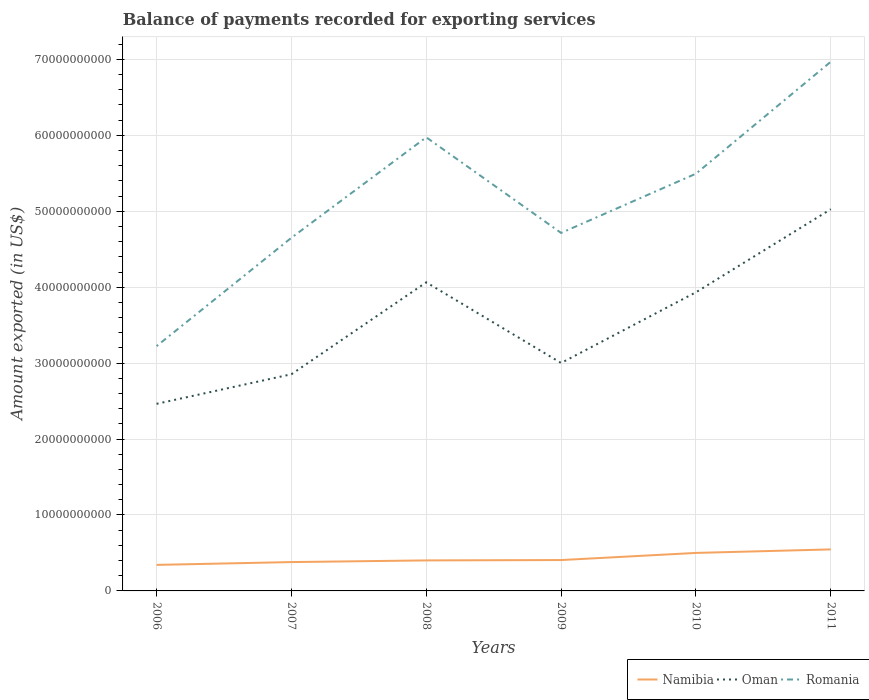How many different coloured lines are there?
Give a very brief answer. 3. Does the line corresponding to Oman intersect with the line corresponding to Namibia?
Your answer should be very brief. No. Is the number of lines equal to the number of legend labels?
Provide a succinct answer. Yes. Across all years, what is the maximum amount exported in Namibia?
Offer a very short reply. 3.43e+09. In which year was the amount exported in Namibia maximum?
Give a very brief answer. 2006. What is the total amount exported in Oman in the graph?
Your answer should be compact. -1.47e+1. What is the difference between the highest and the second highest amount exported in Oman?
Offer a terse response. 2.56e+1. What is the difference between the highest and the lowest amount exported in Romania?
Your response must be concise. 3. Is the amount exported in Oman strictly greater than the amount exported in Romania over the years?
Your answer should be compact. Yes. How many years are there in the graph?
Keep it short and to the point. 6. What is the difference between two consecutive major ticks on the Y-axis?
Your answer should be very brief. 1.00e+1. Does the graph contain any zero values?
Make the answer very short. No. How are the legend labels stacked?
Offer a terse response. Horizontal. What is the title of the graph?
Offer a very short reply. Balance of payments recorded for exporting services. What is the label or title of the X-axis?
Provide a short and direct response. Years. What is the label or title of the Y-axis?
Make the answer very short. Amount exported (in US$). What is the Amount exported (in US$) in Namibia in 2006?
Offer a terse response. 3.43e+09. What is the Amount exported (in US$) in Oman in 2006?
Provide a succinct answer. 2.46e+1. What is the Amount exported (in US$) of Romania in 2006?
Your answer should be very brief. 3.22e+1. What is the Amount exported (in US$) of Namibia in 2007?
Your response must be concise. 3.80e+09. What is the Amount exported (in US$) of Oman in 2007?
Offer a terse response. 2.85e+1. What is the Amount exported (in US$) of Romania in 2007?
Offer a terse response. 4.65e+1. What is the Amount exported (in US$) of Namibia in 2008?
Keep it short and to the point. 4.02e+09. What is the Amount exported (in US$) of Oman in 2008?
Keep it short and to the point. 4.06e+1. What is the Amount exported (in US$) of Romania in 2008?
Give a very brief answer. 5.97e+1. What is the Amount exported (in US$) in Namibia in 2009?
Offer a terse response. 4.07e+09. What is the Amount exported (in US$) in Oman in 2009?
Provide a short and direct response. 3.00e+1. What is the Amount exported (in US$) in Romania in 2009?
Your answer should be very brief. 4.72e+1. What is the Amount exported (in US$) in Namibia in 2010?
Provide a succinct answer. 5.00e+09. What is the Amount exported (in US$) of Oman in 2010?
Your response must be concise. 3.93e+1. What is the Amount exported (in US$) in Romania in 2010?
Keep it short and to the point. 5.50e+1. What is the Amount exported (in US$) in Namibia in 2011?
Provide a succinct answer. 5.47e+09. What is the Amount exported (in US$) in Oman in 2011?
Your response must be concise. 5.03e+1. What is the Amount exported (in US$) in Romania in 2011?
Make the answer very short. 6.97e+1. Across all years, what is the maximum Amount exported (in US$) of Namibia?
Your response must be concise. 5.47e+09. Across all years, what is the maximum Amount exported (in US$) in Oman?
Your answer should be very brief. 5.03e+1. Across all years, what is the maximum Amount exported (in US$) of Romania?
Keep it short and to the point. 6.97e+1. Across all years, what is the minimum Amount exported (in US$) in Namibia?
Provide a short and direct response. 3.43e+09. Across all years, what is the minimum Amount exported (in US$) of Oman?
Your answer should be compact. 2.46e+1. Across all years, what is the minimum Amount exported (in US$) in Romania?
Offer a very short reply. 3.22e+1. What is the total Amount exported (in US$) of Namibia in the graph?
Give a very brief answer. 2.58e+1. What is the total Amount exported (in US$) of Oman in the graph?
Give a very brief answer. 2.13e+11. What is the total Amount exported (in US$) of Romania in the graph?
Make the answer very short. 3.10e+11. What is the difference between the Amount exported (in US$) of Namibia in 2006 and that in 2007?
Give a very brief answer. -3.70e+08. What is the difference between the Amount exported (in US$) in Oman in 2006 and that in 2007?
Your response must be concise. -3.90e+09. What is the difference between the Amount exported (in US$) in Romania in 2006 and that in 2007?
Give a very brief answer. -1.43e+1. What is the difference between the Amount exported (in US$) of Namibia in 2006 and that in 2008?
Provide a short and direct response. -5.91e+08. What is the difference between the Amount exported (in US$) in Oman in 2006 and that in 2008?
Keep it short and to the point. -1.60e+1. What is the difference between the Amount exported (in US$) in Romania in 2006 and that in 2008?
Keep it short and to the point. -2.75e+1. What is the difference between the Amount exported (in US$) in Namibia in 2006 and that in 2009?
Ensure brevity in your answer.  -6.37e+08. What is the difference between the Amount exported (in US$) of Oman in 2006 and that in 2009?
Your answer should be compact. -5.38e+09. What is the difference between the Amount exported (in US$) in Romania in 2006 and that in 2009?
Your response must be concise. -1.49e+1. What is the difference between the Amount exported (in US$) of Namibia in 2006 and that in 2010?
Keep it short and to the point. -1.58e+09. What is the difference between the Amount exported (in US$) in Oman in 2006 and that in 2010?
Ensure brevity in your answer.  -1.47e+1. What is the difference between the Amount exported (in US$) in Romania in 2006 and that in 2010?
Your response must be concise. -2.27e+1. What is the difference between the Amount exported (in US$) of Namibia in 2006 and that in 2011?
Ensure brevity in your answer.  -2.04e+09. What is the difference between the Amount exported (in US$) of Oman in 2006 and that in 2011?
Offer a very short reply. -2.56e+1. What is the difference between the Amount exported (in US$) of Romania in 2006 and that in 2011?
Provide a short and direct response. -3.75e+1. What is the difference between the Amount exported (in US$) in Namibia in 2007 and that in 2008?
Provide a succinct answer. -2.21e+08. What is the difference between the Amount exported (in US$) of Oman in 2007 and that in 2008?
Offer a very short reply. -1.21e+1. What is the difference between the Amount exported (in US$) of Romania in 2007 and that in 2008?
Offer a very short reply. -1.32e+1. What is the difference between the Amount exported (in US$) of Namibia in 2007 and that in 2009?
Offer a terse response. -2.67e+08. What is the difference between the Amount exported (in US$) of Oman in 2007 and that in 2009?
Your answer should be compact. -1.49e+09. What is the difference between the Amount exported (in US$) in Romania in 2007 and that in 2009?
Your answer should be compact. -6.41e+08. What is the difference between the Amount exported (in US$) in Namibia in 2007 and that in 2010?
Your response must be concise. -1.21e+09. What is the difference between the Amount exported (in US$) of Oman in 2007 and that in 2010?
Offer a very short reply. -1.08e+1. What is the difference between the Amount exported (in US$) in Romania in 2007 and that in 2010?
Keep it short and to the point. -8.44e+09. What is the difference between the Amount exported (in US$) of Namibia in 2007 and that in 2011?
Give a very brief answer. -1.67e+09. What is the difference between the Amount exported (in US$) in Oman in 2007 and that in 2011?
Your answer should be compact. -2.17e+1. What is the difference between the Amount exported (in US$) in Romania in 2007 and that in 2011?
Provide a succinct answer. -2.32e+1. What is the difference between the Amount exported (in US$) in Namibia in 2008 and that in 2009?
Offer a terse response. -4.59e+07. What is the difference between the Amount exported (in US$) of Oman in 2008 and that in 2009?
Provide a short and direct response. 1.06e+1. What is the difference between the Amount exported (in US$) of Romania in 2008 and that in 2009?
Your answer should be compact. 1.26e+1. What is the difference between the Amount exported (in US$) in Namibia in 2008 and that in 2010?
Keep it short and to the point. -9.84e+08. What is the difference between the Amount exported (in US$) of Oman in 2008 and that in 2010?
Ensure brevity in your answer.  1.31e+09. What is the difference between the Amount exported (in US$) in Romania in 2008 and that in 2010?
Give a very brief answer. 4.79e+09. What is the difference between the Amount exported (in US$) of Namibia in 2008 and that in 2011?
Your response must be concise. -1.45e+09. What is the difference between the Amount exported (in US$) of Oman in 2008 and that in 2011?
Give a very brief answer. -9.63e+09. What is the difference between the Amount exported (in US$) of Romania in 2008 and that in 2011?
Your answer should be very brief. -9.96e+09. What is the difference between the Amount exported (in US$) in Namibia in 2009 and that in 2010?
Offer a terse response. -9.39e+08. What is the difference between the Amount exported (in US$) in Oman in 2009 and that in 2010?
Provide a succinct answer. -9.31e+09. What is the difference between the Amount exported (in US$) in Romania in 2009 and that in 2010?
Give a very brief answer. -7.80e+09. What is the difference between the Amount exported (in US$) of Namibia in 2009 and that in 2011?
Offer a very short reply. -1.40e+09. What is the difference between the Amount exported (in US$) of Oman in 2009 and that in 2011?
Ensure brevity in your answer.  -2.02e+1. What is the difference between the Amount exported (in US$) of Romania in 2009 and that in 2011?
Give a very brief answer. -2.25e+1. What is the difference between the Amount exported (in US$) in Namibia in 2010 and that in 2011?
Offer a very short reply. -4.64e+08. What is the difference between the Amount exported (in US$) in Oman in 2010 and that in 2011?
Your answer should be compact. -1.09e+1. What is the difference between the Amount exported (in US$) of Romania in 2010 and that in 2011?
Make the answer very short. -1.47e+1. What is the difference between the Amount exported (in US$) in Namibia in 2006 and the Amount exported (in US$) in Oman in 2007?
Give a very brief answer. -2.51e+1. What is the difference between the Amount exported (in US$) in Namibia in 2006 and the Amount exported (in US$) in Romania in 2007?
Your answer should be very brief. -4.31e+1. What is the difference between the Amount exported (in US$) of Oman in 2006 and the Amount exported (in US$) of Romania in 2007?
Provide a short and direct response. -2.19e+1. What is the difference between the Amount exported (in US$) in Namibia in 2006 and the Amount exported (in US$) in Oman in 2008?
Give a very brief answer. -3.72e+1. What is the difference between the Amount exported (in US$) of Namibia in 2006 and the Amount exported (in US$) of Romania in 2008?
Give a very brief answer. -5.63e+1. What is the difference between the Amount exported (in US$) in Oman in 2006 and the Amount exported (in US$) in Romania in 2008?
Give a very brief answer. -3.51e+1. What is the difference between the Amount exported (in US$) in Namibia in 2006 and the Amount exported (in US$) in Oman in 2009?
Make the answer very short. -2.66e+1. What is the difference between the Amount exported (in US$) in Namibia in 2006 and the Amount exported (in US$) in Romania in 2009?
Offer a terse response. -4.37e+1. What is the difference between the Amount exported (in US$) of Oman in 2006 and the Amount exported (in US$) of Romania in 2009?
Provide a short and direct response. -2.25e+1. What is the difference between the Amount exported (in US$) of Namibia in 2006 and the Amount exported (in US$) of Oman in 2010?
Your response must be concise. -3.59e+1. What is the difference between the Amount exported (in US$) of Namibia in 2006 and the Amount exported (in US$) of Romania in 2010?
Your answer should be compact. -5.15e+1. What is the difference between the Amount exported (in US$) in Oman in 2006 and the Amount exported (in US$) in Romania in 2010?
Offer a very short reply. -3.03e+1. What is the difference between the Amount exported (in US$) in Namibia in 2006 and the Amount exported (in US$) in Oman in 2011?
Your answer should be very brief. -4.68e+1. What is the difference between the Amount exported (in US$) of Namibia in 2006 and the Amount exported (in US$) of Romania in 2011?
Provide a short and direct response. -6.63e+1. What is the difference between the Amount exported (in US$) in Oman in 2006 and the Amount exported (in US$) in Romania in 2011?
Your response must be concise. -4.51e+1. What is the difference between the Amount exported (in US$) in Namibia in 2007 and the Amount exported (in US$) in Oman in 2008?
Offer a very short reply. -3.68e+1. What is the difference between the Amount exported (in US$) in Namibia in 2007 and the Amount exported (in US$) in Romania in 2008?
Keep it short and to the point. -5.59e+1. What is the difference between the Amount exported (in US$) of Oman in 2007 and the Amount exported (in US$) of Romania in 2008?
Offer a terse response. -3.12e+1. What is the difference between the Amount exported (in US$) of Namibia in 2007 and the Amount exported (in US$) of Oman in 2009?
Ensure brevity in your answer.  -2.62e+1. What is the difference between the Amount exported (in US$) of Namibia in 2007 and the Amount exported (in US$) of Romania in 2009?
Your answer should be very brief. -4.34e+1. What is the difference between the Amount exported (in US$) of Oman in 2007 and the Amount exported (in US$) of Romania in 2009?
Give a very brief answer. -1.86e+1. What is the difference between the Amount exported (in US$) in Namibia in 2007 and the Amount exported (in US$) in Oman in 2010?
Keep it short and to the point. -3.55e+1. What is the difference between the Amount exported (in US$) of Namibia in 2007 and the Amount exported (in US$) of Romania in 2010?
Your answer should be compact. -5.12e+1. What is the difference between the Amount exported (in US$) in Oman in 2007 and the Amount exported (in US$) in Romania in 2010?
Make the answer very short. -2.64e+1. What is the difference between the Amount exported (in US$) in Namibia in 2007 and the Amount exported (in US$) in Oman in 2011?
Keep it short and to the point. -4.65e+1. What is the difference between the Amount exported (in US$) of Namibia in 2007 and the Amount exported (in US$) of Romania in 2011?
Offer a terse response. -6.59e+1. What is the difference between the Amount exported (in US$) of Oman in 2007 and the Amount exported (in US$) of Romania in 2011?
Keep it short and to the point. -4.12e+1. What is the difference between the Amount exported (in US$) in Namibia in 2008 and the Amount exported (in US$) in Oman in 2009?
Give a very brief answer. -2.60e+1. What is the difference between the Amount exported (in US$) of Namibia in 2008 and the Amount exported (in US$) of Romania in 2009?
Keep it short and to the point. -4.31e+1. What is the difference between the Amount exported (in US$) of Oman in 2008 and the Amount exported (in US$) of Romania in 2009?
Offer a very short reply. -6.51e+09. What is the difference between the Amount exported (in US$) of Namibia in 2008 and the Amount exported (in US$) of Oman in 2010?
Give a very brief answer. -3.53e+1. What is the difference between the Amount exported (in US$) of Namibia in 2008 and the Amount exported (in US$) of Romania in 2010?
Offer a very short reply. -5.09e+1. What is the difference between the Amount exported (in US$) in Oman in 2008 and the Amount exported (in US$) in Romania in 2010?
Give a very brief answer. -1.43e+1. What is the difference between the Amount exported (in US$) of Namibia in 2008 and the Amount exported (in US$) of Oman in 2011?
Make the answer very short. -4.62e+1. What is the difference between the Amount exported (in US$) in Namibia in 2008 and the Amount exported (in US$) in Romania in 2011?
Provide a short and direct response. -6.57e+1. What is the difference between the Amount exported (in US$) of Oman in 2008 and the Amount exported (in US$) of Romania in 2011?
Your answer should be very brief. -2.91e+1. What is the difference between the Amount exported (in US$) of Namibia in 2009 and the Amount exported (in US$) of Oman in 2010?
Offer a terse response. -3.53e+1. What is the difference between the Amount exported (in US$) of Namibia in 2009 and the Amount exported (in US$) of Romania in 2010?
Provide a short and direct response. -5.09e+1. What is the difference between the Amount exported (in US$) of Oman in 2009 and the Amount exported (in US$) of Romania in 2010?
Your answer should be very brief. -2.49e+1. What is the difference between the Amount exported (in US$) in Namibia in 2009 and the Amount exported (in US$) in Oman in 2011?
Keep it short and to the point. -4.62e+1. What is the difference between the Amount exported (in US$) in Namibia in 2009 and the Amount exported (in US$) in Romania in 2011?
Provide a short and direct response. -6.56e+1. What is the difference between the Amount exported (in US$) in Oman in 2009 and the Amount exported (in US$) in Romania in 2011?
Provide a succinct answer. -3.97e+1. What is the difference between the Amount exported (in US$) of Namibia in 2010 and the Amount exported (in US$) of Oman in 2011?
Your response must be concise. -4.53e+1. What is the difference between the Amount exported (in US$) of Namibia in 2010 and the Amount exported (in US$) of Romania in 2011?
Your response must be concise. -6.47e+1. What is the difference between the Amount exported (in US$) in Oman in 2010 and the Amount exported (in US$) in Romania in 2011?
Keep it short and to the point. -3.04e+1. What is the average Amount exported (in US$) in Namibia per year?
Make the answer very short. 4.30e+09. What is the average Amount exported (in US$) in Oman per year?
Your answer should be compact. 3.56e+1. What is the average Amount exported (in US$) in Romania per year?
Offer a terse response. 5.17e+1. In the year 2006, what is the difference between the Amount exported (in US$) of Namibia and Amount exported (in US$) of Oman?
Offer a very short reply. -2.12e+1. In the year 2006, what is the difference between the Amount exported (in US$) of Namibia and Amount exported (in US$) of Romania?
Offer a very short reply. -2.88e+1. In the year 2006, what is the difference between the Amount exported (in US$) of Oman and Amount exported (in US$) of Romania?
Ensure brevity in your answer.  -7.60e+09. In the year 2007, what is the difference between the Amount exported (in US$) in Namibia and Amount exported (in US$) in Oman?
Your answer should be compact. -2.47e+1. In the year 2007, what is the difference between the Amount exported (in US$) in Namibia and Amount exported (in US$) in Romania?
Give a very brief answer. -4.27e+1. In the year 2007, what is the difference between the Amount exported (in US$) in Oman and Amount exported (in US$) in Romania?
Keep it short and to the point. -1.80e+1. In the year 2008, what is the difference between the Amount exported (in US$) of Namibia and Amount exported (in US$) of Oman?
Ensure brevity in your answer.  -3.66e+1. In the year 2008, what is the difference between the Amount exported (in US$) in Namibia and Amount exported (in US$) in Romania?
Your answer should be very brief. -5.57e+1. In the year 2008, what is the difference between the Amount exported (in US$) in Oman and Amount exported (in US$) in Romania?
Keep it short and to the point. -1.91e+1. In the year 2009, what is the difference between the Amount exported (in US$) of Namibia and Amount exported (in US$) of Oman?
Provide a succinct answer. -2.60e+1. In the year 2009, what is the difference between the Amount exported (in US$) in Namibia and Amount exported (in US$) in Romania?
Offer a very short reply. -4.31e+1. In the year 2009, what is the difference between the Amount exported (in US$) of Oman and Amount exported (in US$) of Romania?
Provide a succinct answer. -1.71e+1. In the year 2010, what is the difference between the Amount exported (in US$) in Namibia and Amount exported (in US$) in Oman?
Offer a very short reply. -3.43e+1. In the year 2010, what is the difference between the Amount exported (in US$) in Namibia and Amount exported (in US$) in Romania?
Offer a very short reply. -4.99e+1. In the year 2010, what is the difference between the Amount exported (in US$) in Oman and Amount exported (in US$) in Romania?
Offer a very short reply. -1.56e+1. In the year 2011, what is the difference between the Amount exported (in US$) of Namibia and Amount exported (in US$) of Oman?
Provide a succinct answer. -4.48e+1. In the year 2011, what is the difference between the Amount exported (in US$) of Namibia and Amount exported (in US$) of Romania?
Provide a succinct answer. -6.42e+1. In the year 2011, what is the difference between the Amount exported (in US$) of Oman and Amount exported (in US$) of Romania?
Offer a very short reply. -1.94e+1. What is the ratio of the Amount exported (in US$) in Namibia in 2006 to that in 2007?
Offer a terse response. 0.9. What is the ratio of the Amount exported (in US$) in Oman in 2006 to that in 2007?
Your answer should be very brief. 0.86. What is the ratio of the Amount exported (in US$) in Romania in 2006 to that in 2007?
Your answer should be very brief. 0.69. What is the ratio of the Amount exported (in US$) in Namibia in 2006 to that in 2008?
Provide a short and direct response. 0.85. What is the ratio of the Amount exported (in US$) of Oman in 2006 to that in 2008?
Keep it short and to the point. 0.61. What is the ratio of the Amount exported (in US$) in Romania in 2006 to that in 2008?
Your answer should be very brief. 0.54. What is the ratio of the Amount exported (in US$) of Namibia in 2006 to that in 2009?
Make the answer very short. 0.84. What is the ratio of the Amount exported (in US$) in Oman in 2006 to that in 2009?
Ensure brevity in your answer.  0.82. What is the ratio of the Amount exported (in US$) of Romania in 2006 to that in 2009?
Provide a succinct answer. 0.68. What is the ratio of the Amount exported (in US$) of Namibia in 2006 to that in 2010?
Keep it short and to the point. 0.69. What is the ratio of the Amount exported (in US$) of Oman in 2006 to that in 2010?
Offer a terse response. 0.63. What is the ratio of the Amount exported (in US$) in Romania in 2006 to that in 2010?
Your answer should be compact. 0.59. What is the ratio of the Amount exported (in US$) of Namibia in 2006 to that in 2011?
Your response must be concise. 0.63. What is the ratio of the Amount exported (in US$) in Oman in 2006 to that in 2011?
Offer a very short reply. 0.49. What is the ratio of the Amount exported (in US$) of Romania in 2006 to that in 2011?
Your response must be concise. 0.46. What is the ratio of the Amount exported (in US$) in Namibia in 2007 to that in 2008?
Give a very brief answer. 0.94. What is the ratio of the Amount exported (in US$) of Oman in 2007 to that in 2008?
Make the answer very short. 0.7. What is the ratio of the Amount exported (in US$) of Romania in 2007 to that in 2008?
Provide a short and direct response. 0.78. What is the ratio of the Amount exported (in US$) in Namibia in 2007 to that in 2009?
Provide a short and direct response. 0.93. What is the ratio of the Amount exported (in US$) in Oman in 2007 to that in 2009?
Keep it short and to the point. 0.95. What is the ratio of the Amount exported (in US$) in Romania in 2007 to that in 2009?
Provide a short and direct response. 0.99. What is the ratio of the Amount exported (in US$) of Namibia in 2007 to that in 2010?
Give a very brief answer. 0.76. What is the ratio of the Amount exported (in US$) in Oman in 2007 to that in 2010?
Keep it short and to the point. 0.73. What is the ratio of the Amount exported (in US$) in Romania in 2007 to that in 2010?
Offer a very short reply. 0.85. What is the ratio of the Amount exported (in US$) of Namibia in 2007 to that in 2011?
Provide a short and direct response. 0.69. What is the ratio of the Amount exported (in US$) in Oman in 2007 to that in 2011?
Your answer should be compact. 0.57. What is the ratio of the Amount exported (in US$) in Romania in 2007 to that in 2011?
Offer a very short reply. 0.67. What is the ratio of the Amount exported (in US$) of Namibia in 2008 to that in 2009?
Provide a succinct answer. 0.99. What is the ratio of the Amount exported (in US$) in Oman in 2008 to that in 2009?
Provide a short and direct response. 1.35. What is the ratio of the Amount exported (in US$) in Romania in 2008 to that in 2009?
Your answer should be very brief. 1.27. What is the ratio of the Amount exported (in US$) in Namibia in 2008 to that in 2010?
Your response must be concise. 0.8. What is the ratio of the Amount exported (in US$) in Oman in 2008 to that in 2010?
Keep it short and to the point. 1.03. What is the ratio of the Amount exported (in US$) of Romania in 2008 to that in 2010?
Keep it short and to the point. 1.09. What is the ratio of the Amount exported (in US$) of Namibia in 2008 to that in 2011?
Offer a terse response. 0.74. What is the ratio of the Amount exported (in US$) in Oman in 2008 to that in 2011?
Your answer should be very brief. 0.81. What is the ratio of the Amount exported (in US$) of Romania in 2008 to that in 2011?
Your answer should be compact. 0.86. What is the ratio of the Amount exported (in US$) of Namibia in 2009 to that in 2010?
Offer a very short reply. 0.81. What is the ratio of the Amount exported (in US$) of Oman in 2009 to that in 2010?
Give a very brief answer. 0.76. What is the ratio of the Amount exported (in US$) of Romania in 2009 to that in 2010?
Provide a succinct answer. 0.86. What is the ratio of the Amount exported (in US$) of Namibia in 2009 to that in 2011?
Your answer should be very brief. 0.74. What is the ratio of the Amount exported (in US$) of Oman in 2009 to that in 2011?
Provide a succinct answer. 0.6. What is the ratio of the Amount exported (in US$) of Romania in 2009 to that in 2011?
Offer a very short reply. 0.68. What is the ratio of the Amount exported (in US$) of Namibia in 2010 to that in 2011?
Provide a short and direct response. 0.92. What is the ratio of the Amount exported (in US$) in Oman in 2010 to that in 2011?
Give a very brief answer. 0.78. What is the ratio of the Amount exported (in US$) of Romania in 2010 to that in 2011?
Ensure brevity in your answer.  0.79. What is the difference between the highest and the second highest Amount exported (in US$) in Namibia?
Give a very brief answer. 4.64e+08. What is the difference between the highest and the second highest Amount exported (in US$) of Oman?
Ensure brevity in your answer.  9.63e+09. What is the difference between the highest and the second highest Amount exported (in US$) of Romania?
Your answer should be compact. 9.96e+09. What is the difference between the highest and the lowest Amount exported (in US$) of Namibia?
Offer a very short reply. 2.04e+09. What is the difference between the highest and the lowest Amount exported (in US$) in Oman?
Your answer should be compact. 2.56e+1. What is the difference between the highest and the lowest Amount exported (in US$) in Romania?
Offer a terse response. 3.75e+1. 